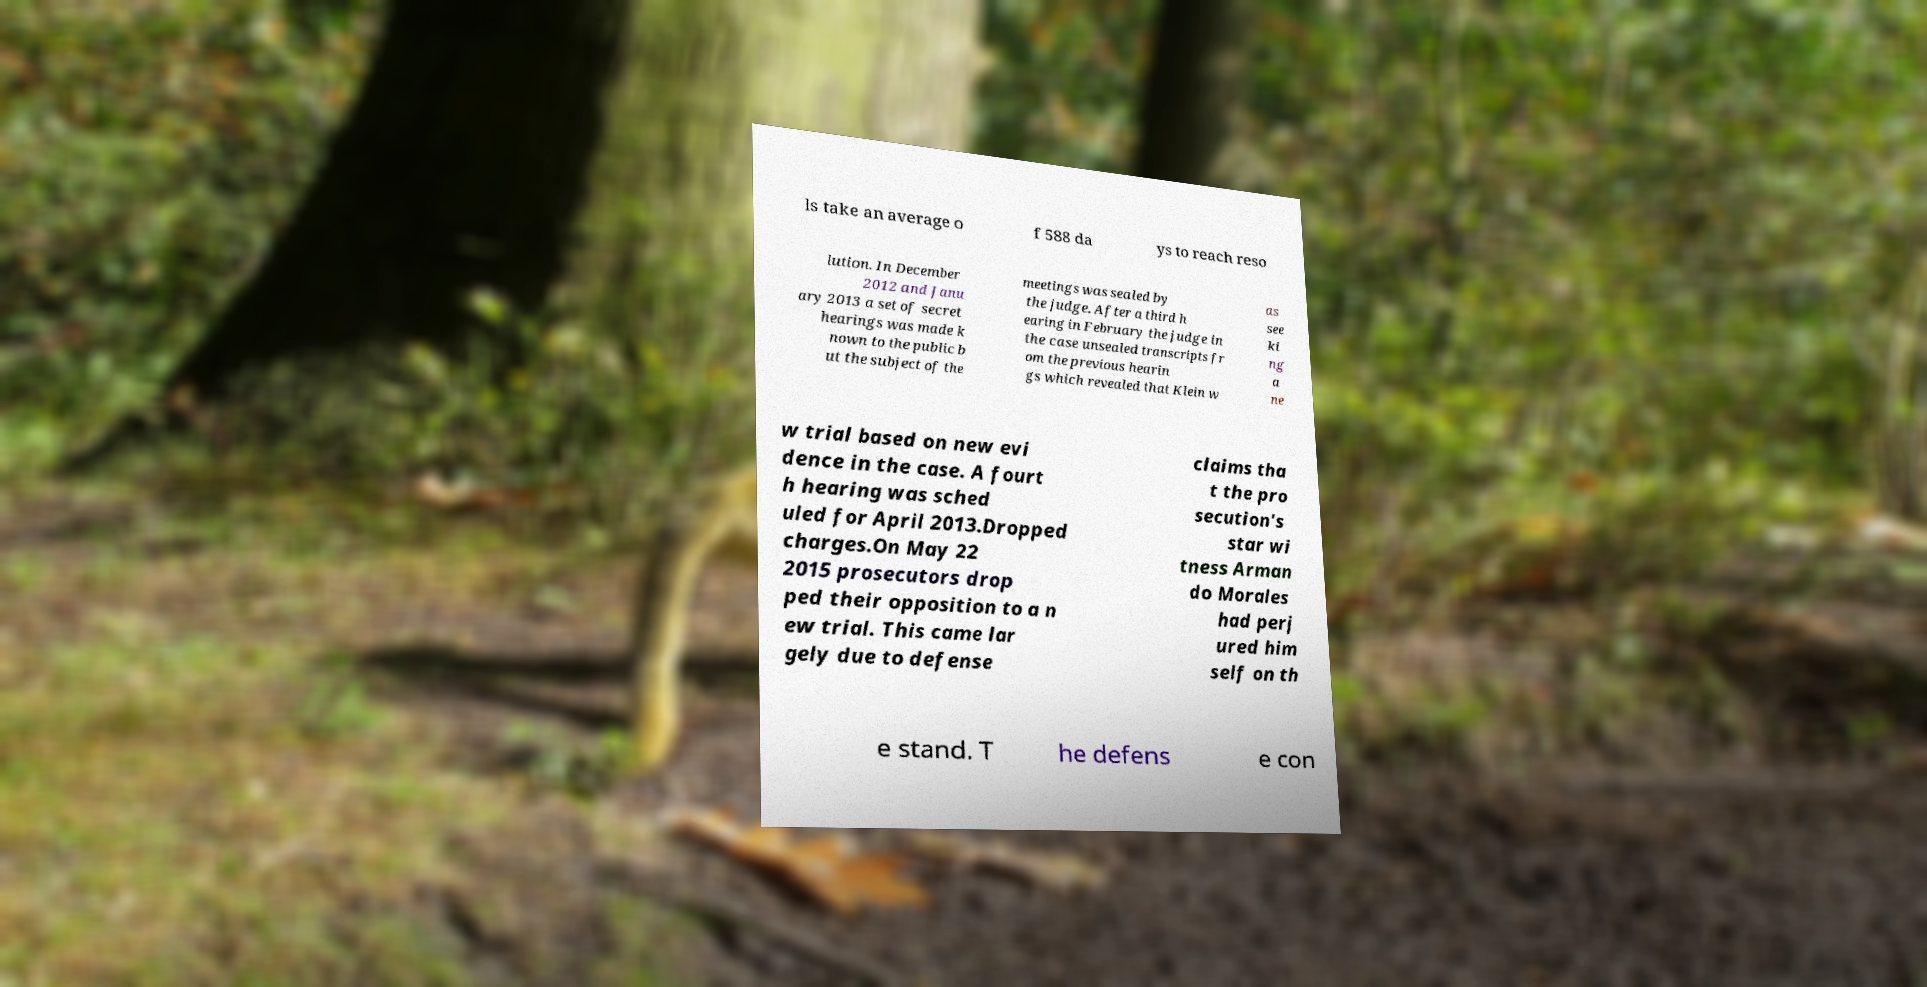Please identify and transcribe the text found in this image. ls take an average o f 588 da ys to reach reso lution. In December 2012 and Janu ary 2013 a set of secret hearings was made k nown to the public b ut the subject of the meetings was sealed by the judge. After a third h earing in February the judge in the case unsealed transcripts fr om the previous hearin gs which revealed that Klein w as see ki ng a ne w trial based on new evi dence in the case. A fourt h hearing was sched uled for April 2013.Dropped charges.On May 22 2015 prosecutors drop ped their opposition to a n ew trial. This came lar gely due to defense claims tha t the pro secution's star wi tness Arman do Morales had perj ured him self on th e stand. T he defens e con 